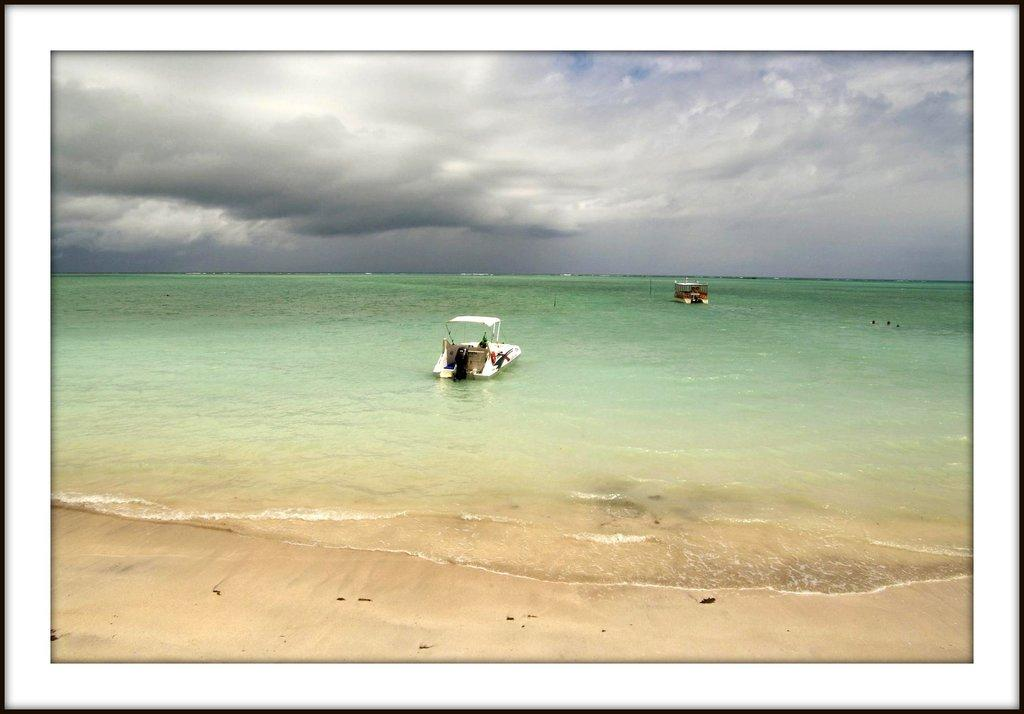What is the main subject of the image? There is a picture in the image. What is depicted in the picture? The picture contains ships on the sea. sea. What can be seen in the background of the picture? The sky is visible in the background of the picture. What is the condition of the sky in the background of the picture? Clouds are present in the sky in the background of the picture. What type of drink can be seen in the nest in the image? There is no drink or nest present in the image. Who is the judge in the image? There is no judge present in the image. 